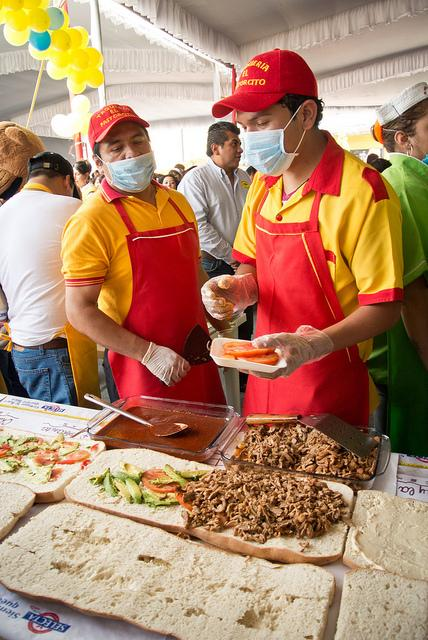These people are making what kind of food? Please explain your reasoning. mexican. The food is being wrapped up in a burrito wrap. 